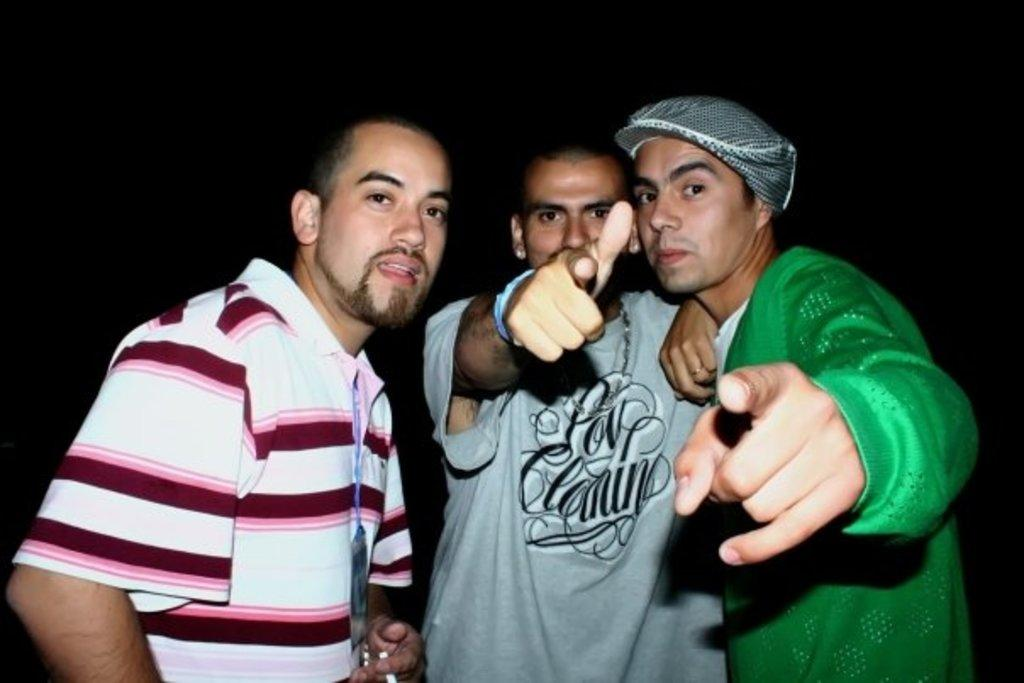How many people are in the image? There are three men standing in the image. Can you describe the clothing of one of the men? One of the men is wearing a cap. What can be observed about the lighting in the image? The background of the image appears dark. What type of squirrel can be seen climbing the tree in the image? There is no tree or squirrel present in the image; it features three men standing in a scene with a dark background. What is the zinc content of the soil in the image? There is no information about the soil or its zinc content in the image. 